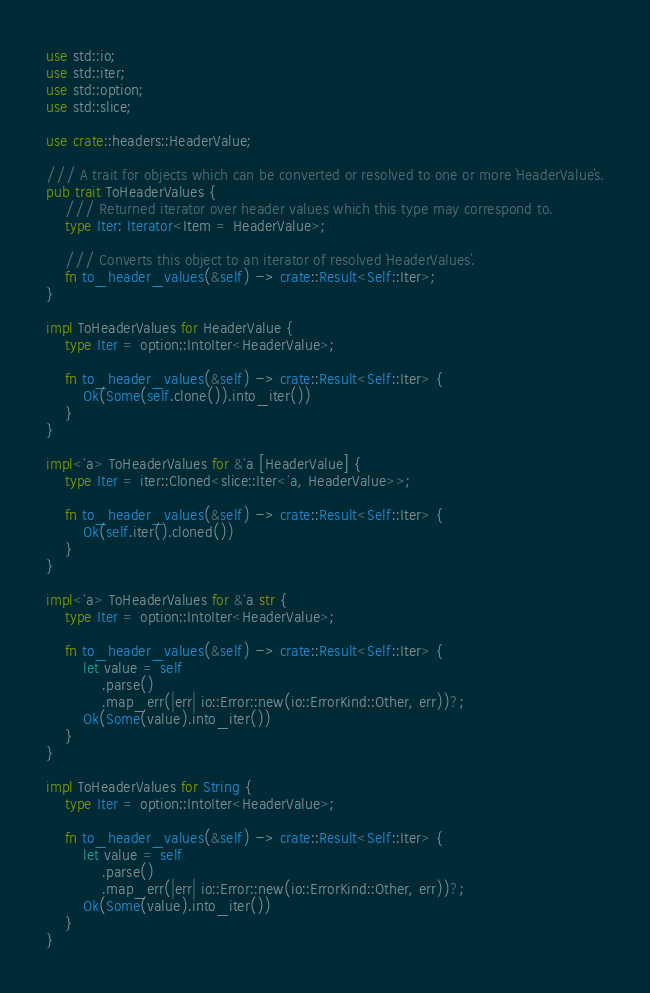Convert code to text. <code><loc_0><loc_0><loc_500><loc_500><_Rust_>use std::io;
use std::iter;
use std::option;
use std::slice;

use crate::headers::HeaderValue;

/// A trait for objects which can be converted or resolved to one or more `HeaderValue`s.
pub trait ToHeaderValues {
    /// Returned iterator over header values which this type may correspond to.
    type Iter: Iterator<Item = HeaderValue>;

    /// Converts this object to an iterator of resolved `HeaderValues`.
    fn to_header_values(&self) -> crate::Result<Self::Iter>;
}

impl ToHeaderValues for HeaderValue {
    type Iter = option::IntoIter<HeaderValue>;

    fn to_header_values(&self) -> crate::Result<Self::Iter> {
        Ok(Some(self.clone()).into_iter())
    }
}

impl<'a> ToHeaderValues for &'a [HeaderValue] {
    type Iter = iter::Cloned<slice::Iter<'a, HeaderValue>>;

    fn to_header_values(&self) -> crate::Result<Self::Iter> {
        Ok(self.iter().cloned())
    }
}

impl<'a> ToHeaderValues for &'a str {
    type Iter = option::IntoIter<HeaderValue>;

    fn to_header_values(&self) -> crate::Result<Self::Iter> {
        let value = self
            .parse()
            .map_err(|err| io::Error::new(io::ErrorKind::Other, err))?;
        Ok(Some(value).into_iter())
    }
}

impl ToHeaderValues for String {
    type Iter = option::IntoIter<HeaderValue>;

    fn to_header_values(&self) -> crate::Result<Self::Iter> {
        let value = self
            .parse()
            .map_err(|err| io::Error::new(io::ErrorKind::Other, err))?;
        Ok(Some(value).into_iter())
    }
}
</code> 